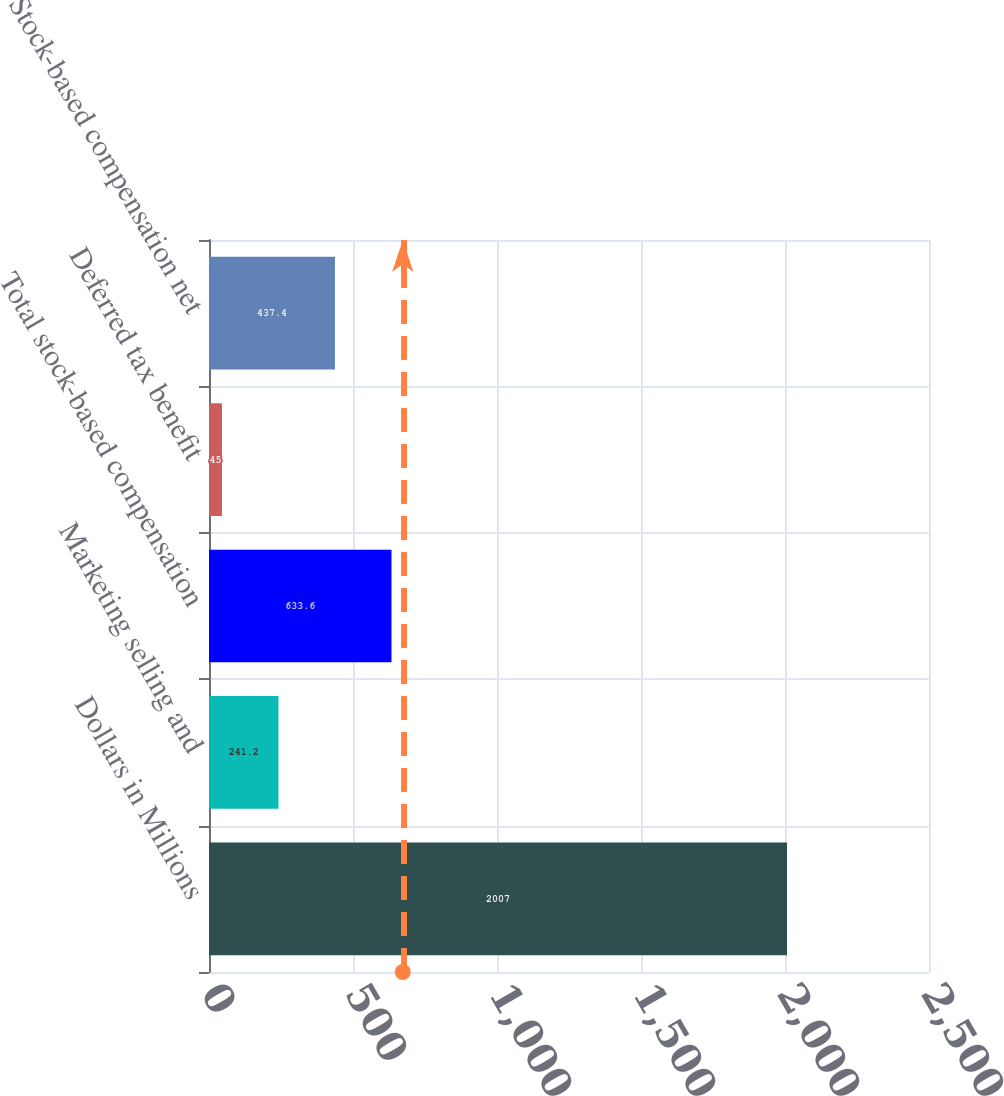<chart> <loc_0><loc_0><loc_500><loc_500><bar_chart><fcel>Dollars in Millions<fcel>Marketing selling and<fcel>Total stock-based compensation<fcel>Deferred tax benefit<fcel>Stock-based compensation net<nl><fcel>2007<fcel>241.2<fcel>633.6<fcel>45<fcel>437.4<nl></chart> 